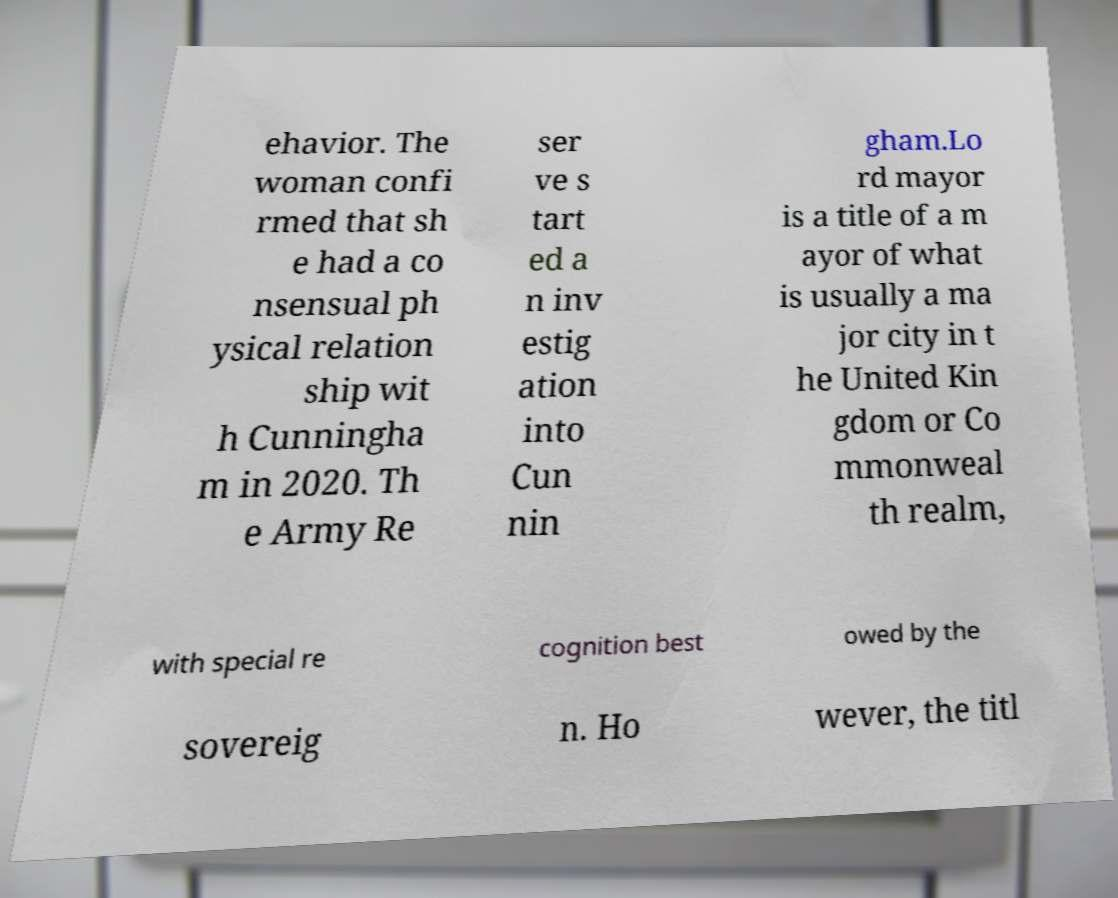Can you accurately transcribe the text from the provided image for me? ehavior. The woman confi rmed that sh e had a co nsensual ph ysical relation ship wit h Cunningha m in 2020. Th e Army Re ser ve s tart ed a n inv estig ation into Cun nin gham.Lo rd mayor is a title of a m ayor of what is usually a ma jor city in t he United Kin gdom or Co mmonweal th realm, with special re cognition best owed by the sovereig n. Ho wever, the titl 